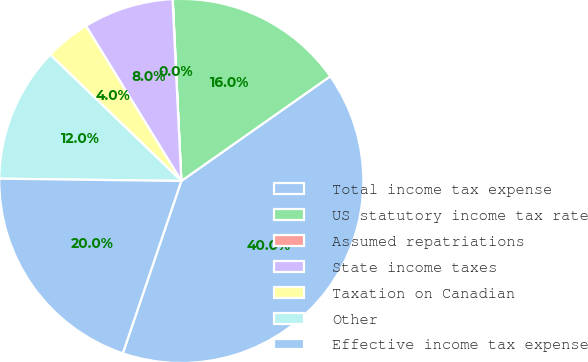Convert chart to OTSL. <chart><loc_0><loc_0><loc_500><loc_500><pie_chart><fcel>Total income tax expense<fcel>US statutory income tax rate<fcel>Assumed repatriations<fcel>State income taxes<fcel>Taxation on Canadian<fcel>Other<fcel>Effective income tax expense<nl><fcel>39.96%<fcel>16.0%<fcel>0.02%<fcel>8.01%<fcel>4.02%<fcel>12.0%<fcel>19.99%<nl></chart> 